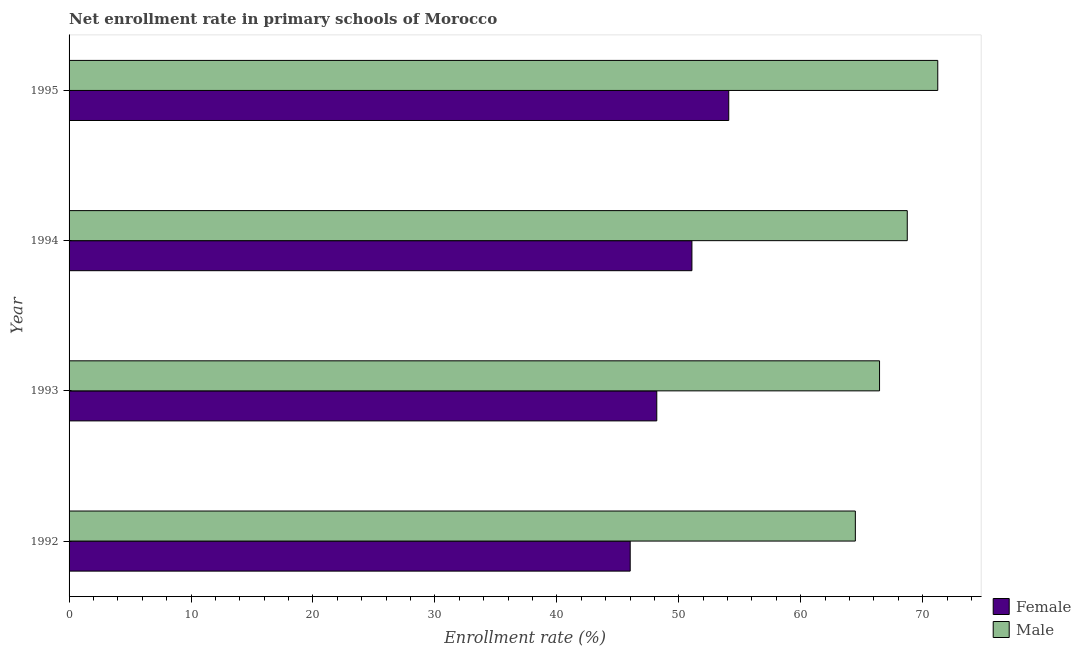How many different coloured bars are there?
Provide a short and direct response. 2. How many groups of bars are there?
Give a very brief answer. 4. Are the number of bars per tick equal to the number of legend labels?
Your response must be concise. Yes. Are the number of bars on each tick of the Y-axis equal?
Provide a succinct answer. Yes. How many bars are there on the 3rd tick from the top?
Offer a terse response. 2. How many bars are there on the 3rd tick from the bottom?
Your answer should be compact. 2. What is the label of the 2nd group of bars from the top?
Ensure brevity in your answer.  1994. What is the enrollment rate of male students in 1992?
Give a very brief answer. 64.48. Across all years, what is the maximum enrollment rate of male students?
Your answer should be compact. 71.24. Across all years, what is the minimum enrollment rate of female students?
Offer a very short reply. 46.02. In which year was the enrollment rate of male students maximum?
Ensure brevity in your answer.  1995. What is the total enrollment rate of male students in the graph?
Offer a terse response. 270.91. What is the difference between the enrollment rate of male students in 1992 and that in 1994?
Provide a short and direct response. -4.26. What is the difference between the enrollment rate of male students in 1994 and the enrollment rate of female students in 1993?
Your response must be concise. 20.54. What is the average enrollment rate of female students per year?
Offer a very short reply. 49.85. In the year 1992, what is the difference between the enrollment rate of male students and enrollment rate of female students?
Offer a terse response. 18.46. In how many years, is the enrollment rate of female students greater than 28 %?
Your answer should be compact. 4. What is the ratio of the enrollment rate of female students in 1993 to that in 1994?
Offer a terse response. 0.94. Is the enrollment rate of male students in 1992 less than that in 1993?
Your answer should be very brief. Yes. Is the difference between the enrollment rate of female students in 1992 and 1995 greater than the difference between the enrollment rate of male students in 1992 and 1995?
Offer a terse response. No. What is the difference between the highest and the second highest enrollment rate of male students?
Keep it short and to the point. 2.5. What is the difference between the highest and the lowest enrollment rate of male students?
Offer a terse response. 6.76. In how many years, is the enrollment rate of female students greater than the average enrollment rate of female students taken over all years?
Your answer should be very brief. 2. Is the sum of the enrollment rate of male students in 1992 and 1995 greater than the maximum enrollment rate of female students across all years?
Provide a short and direct response. Yes. What does the 1st bar from the bottom in 1993 represents?
Your answer should be very brief. Female. How many bars are there?
Provide a short and direct response. 8. What is the difference between two consecutive major ticks on the X-axis?
Ensure brevity in your answer.  10. Are the values on the major ticks of X-axis written in scientific E-notation?
Keep it short and to the point. No. Does the graph contain any zero values?
Provide a succinct answer. No. Where does the legend appear in the graph?
Your response must be concise. Bottom right. How are the legend labels stacked?
Provide a succinct answer. Vertical. What is the title of the graph?
Give a very brief answer. Net enrollment rate in primary schools of Morocco. Does "Export" appear as one of the legend labels in the graph?
Your answer should be very brief. No. What is the label or title of the X-axis?
Your answer should be very brief. Enrollment rate (%). What is the Enrollment rate (%) in Female in 1992?
Your answer should be very brief. 46.02. What is the Enrollment rate (%) in Male in 1992?
Your answer should be very brief. 64.48. What is the Enrollment rate (%) of Female in 1993?
Ensure brevity in your answer.  48.19. What is the Enrollment rate (%) of Male in 1993?
Your answer should be very brief. 66.46. What is the Enrollment rate (%) of Female in 1994?
Provide a succinct answer. 51.08. What is the Enrollment rate (%) in Male in 1994?
Provide a succinct answer. 68.74. What is the Enrollment rate (%) in Female in 1995?
Keep it short and to the point. 54.1. What is the Enrollment rate (%) in Male in 1995?
Keep it short and to the point. 71.24. Across all years, what is the maximum Enrollment rate (%) of Female?
Offer a very short reply. 54.1. Across all years, what is the maximum Enrollment rate (%) of Male?
Make the answer very short. 71.24. Across all years, what is the minimum Enrollment rate (%) in Female?
Your answer should be very brief. 46.02. Across all years, what is the minimum Enrollment rate (%) in Male?
Offer a very short reply. 64.48. What is the total Enrollment rate (%) of Female in the graph?
Your answer should be compact. 199.38. What is the total Enrollment rate (%) in Male in the graph?
Keep it short and to the point. 270.91. What is the difference between the Enrollment rate (%) of Female in 1992 and that in 1993?
Provide a succinct answer. -2.18. What is the difference between the Enrollment rate (%) of Male in 1992 and that in 1993?
Offer a terse response. -1.98. What is the difference between the Enrollment rate (%) of Female in 1992 and that in 1994?
Your answer should be compact. -5.06. What is the difference between the Enrollment rate (%) in Male in 1992 and that in 1994?
Your response must be concise. -4.26. What is the difference between the Enrollment rate (%) of Female in 1992 and that in 1995?
Ensure brevity in your answer.  -8.08. What is the difference between the Enrollment rate (%) of Male in 1992 and that in 1995?
Offer a very short reply. -6.76. What is the difference between the Enrollment rate (%) in Female in 1993 and that in 1994?
Your answer should be very brief. -2.88. What is the difference between the Enrollment rate (%) of Male in 1993 and that in 1994?
Your answer should be compact. -2.27. What is the difference between the Enrollment rate (%) of Female in 1993 and that in 1995?
Offer a very short reply. -5.9. What is the difference between the Enrollment rate (%) of Male in 1993 and that in 1995?
Offer a terse response. -4.77. What is the difference between the Enrollment rate (%) of Female in 1994 and that in 1995?
Provide a short and direct response. -3.02. What is the difference between the Enrollment rate (%) of Male in 1994 and that in 1995?
Offer a terse response. -2.5. What is the difference between the Enrollment rate (%) in Female in 1992 and the Enrollment rate (%) in Male in 1993?
Your answer should be very brief. -20.45. What is the difference between the Enrollment rate (%) in Female in 1992 and the Enrollment rate (%) in Male in 1994?
Provide a short and direct response. -22.72. What is the difference between the Enrollment rate (%) in Female in 1992 and the Enrollment rate (%) in Male in 1995?
Keep it short and to the point. -25.22. What is the difference between the Enrollment rate (%) in Female in 1993 and the Enrollment rate (%) in Male in 1994?
Your response must be concise. -20.54. What is the difference between the Enrollment rate (%) in Female in 1993 and the Enrollment rate (%) in Male in 1995?
Give a very brief answer. -23.04. What is the difference between the Enrollment rate (%) of Female in 1994 and the Enrollment rate (%) of Male in 1995?
Keep it short and to the point. -20.16. What is the average Enrollment rate (%) in Female per year?
Ensure brevity in your answer.  49.85. What is the average Enrollment rate (%) of Male per year?
Offer a terse response. 67.73. In the year 1992, what is the difference between the Enrollment rate (%) in Female and Enrollment rate (%) in Male?
Keep it short and to the point. -18.46. In the year 1993, what is the difference between the Enrollment rate (%) of Female and Enrollment rate (%) of Male?
Give a very brief answer. -18.27. In the year 1994, what is the difference between the Enrollment rate (%) in Female and Enrollment rate (%) in Male?
Your answer should be very brief. -17.66. In the year 1995, what is the difference between the Enrollment rate (%) of Female and Enrollment rate (%) of Male?
Offer a terse response. -17.14. What is the ratio of the Enrollment rate (%) of Female in 1992 to that in 1993?
Your answer should be very brief. 0.95. What is the ratio of the Enrollment rate (%) of Male in 1992 to that in 1993?
Make the answer very short. 0.97. What is the ratio of the Enrollment rate (%) of Female in 1992 to that in 1994?
Your answer should be very brief. 0.9. What is the ratio of the Enrollment rate (%) of Male in 1992 to that in 1994?
Your answer should be very brief. 0.94. What is the ratio of the Enrollment rate (%) of Female in 1992 to that in 1995?
Give a very brief answer. 0.85. What is the ratio of the Enrollment rate (%) of Male in 1992 to that in 1995?
Your answer should be compact. 0.91. What is the ratio of the Enrollment rate (%) in Female in 1993 to that in 1994?
Provide a short and direct response. 0.94. What is the ratio of the Enrollment rate (%) of Male in 1993 to that in 1994?
Your answer should be compact. 0.97. What is the ratio of the Enrollment rate (%) in Female in 1993 to that in 1995?
Give a very brief answer. 0.89. What is the ratio of the Enrollment rate (%) in Male in 1993 to that in 1995?
Give a very brief answer. 0.93. What is the ratio of the Enrollment rate (%) of Female in 1994 to that in 1995?
Your response must be concise. 0.94. What is the ratio of the Enrollment rate (%) in Male in 1994 to that in 1995?
Your answer should be very brief. 0.96. What is the difference between the highest and the second highest Enrollment rate (%) of Female?
Provide a succinct answer. 3.02. What is the difference between the highest and the second highest Enrollment rate (%) of Male?
Offer a terse response. 2.5. What is the difference between the highest and the lowest Enrollment rate (%) in Female?
Your answer should be very brief. 8.08. What is the difference between the highest and the lowest Enrollment rate (%) in Male?
Your response must be concise. 6.76. 